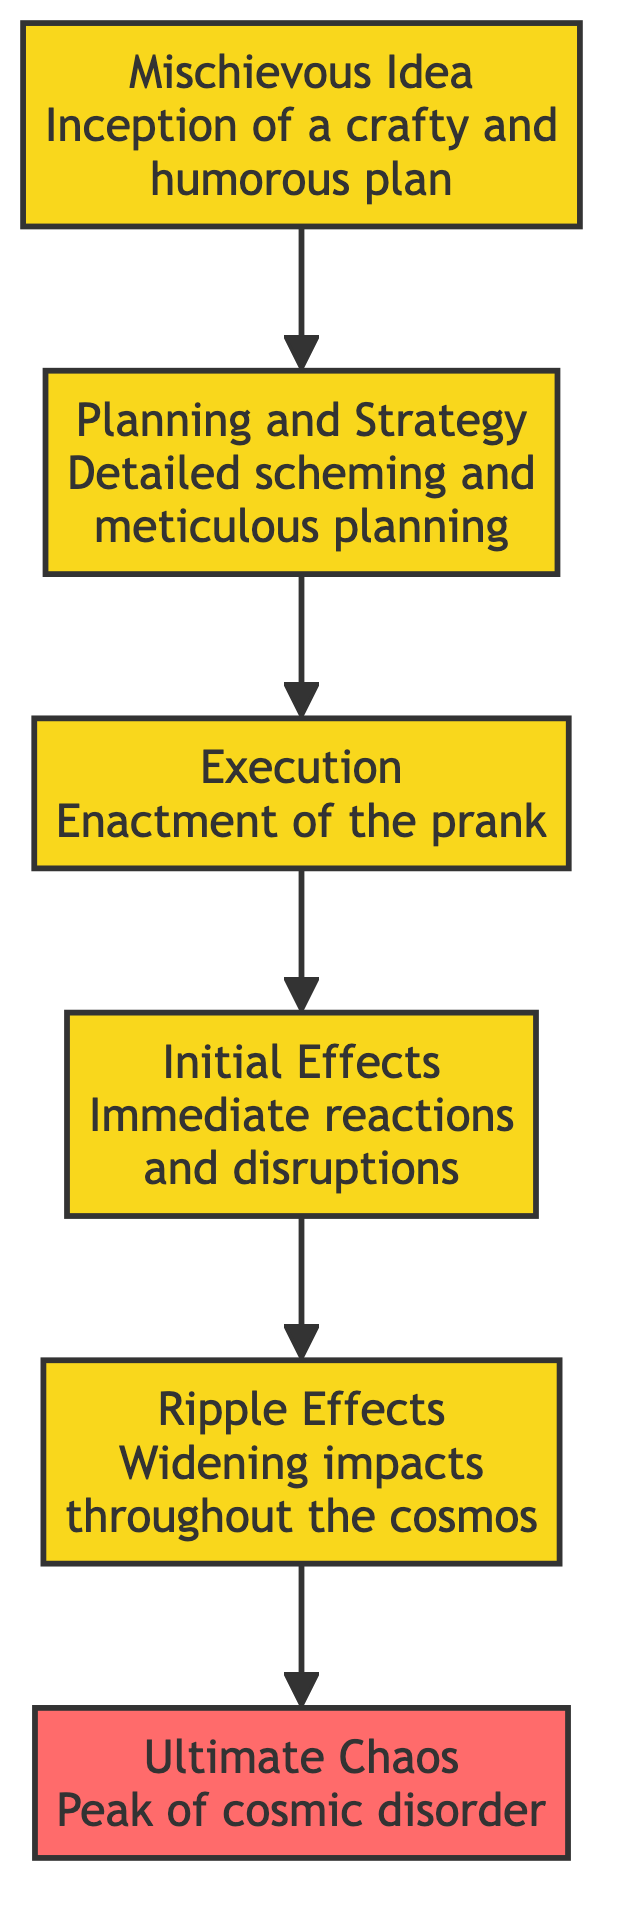What is the topmost stage in the diagram? The topmost stage is marked by the "Ultimate Chaos" section, indicating the final outcome of the journey from conception to cosmic disorder.
Answer: Ultimate Chaos How many stages are there in total? By counting each distinct section in the diagram, there are six stages from the "Mischievous Idea" to the "Ultimate Chaos."
Answer: 6 What comes directly after "Execution"? The stage that follows "Execution" according to the flow is "Initial Effects," which describes the immediate reactions triggered by the prank.
Answer: Initial Effects Which stage describes the reactions affecting nearby entities? The "Initial Effects" stage details the immediate reactions and disruptions caused by the prank and its effects on nearby celestial and metaphysical entities.
Answer: Initial Effects What is the relationship between "Planning and Strategy" and "Ripple Effects"? "Planning and Strategy" is the second stage that precedes the "Ripple Effects," implying the former is essential for the latter to occur after the prank has been executed.
Answer: Planning leads to Ripple Effects What describes the peak of chaos in the universe? The section labeled "Ultimate Chaos" describes the culmination of the prank's journey, where confusion and entropy reign over the universe.
Answer: Ultimate Chaos What are the immediate effects of the prank according to the diagram? The "Initial Effects" stage summarizes the immediate reactions and disruptions caused by the prank after its execution.
Answer: Initial Effects How does the prank evolve through the stages outlined in the diagram? The prank evolves through a sequence of stages starting from "Mischievous Idea," moving to detailed planning, execution, initial impacts, and ultimately leading to widespread chaos in the universe.
Answer: Through sequential stages Which stage has the longest description in the diagram? The "Ripple Effects" stage contains a broader impact description that discusses the unanticipated disorder resulting throughout the cosmos from the prank.
Answer: Ripple Effects 